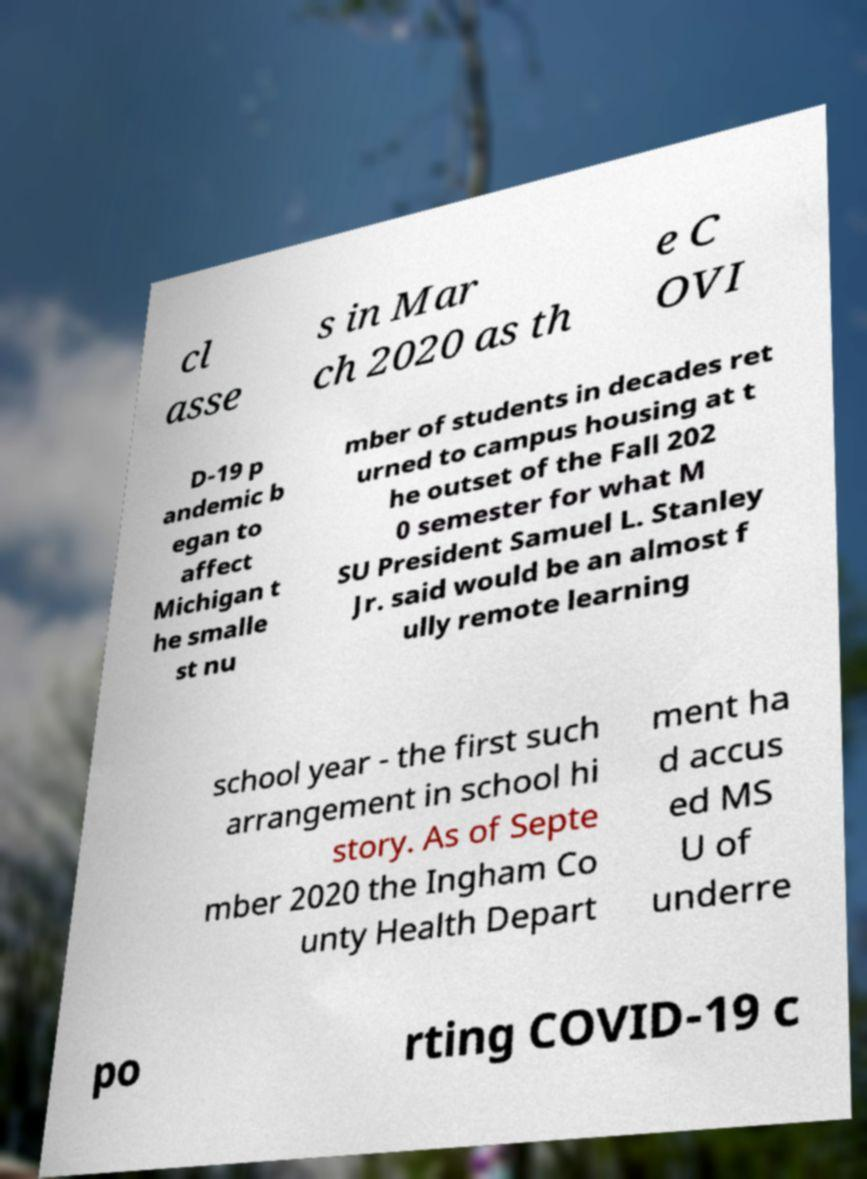Please identify and transcribe the text found in this image. cl asse s in Mar ch 2020 as th e C OVI D-19 p andemic b egan to affect Michigan t he smalle st nu mber of students in decades ret urned to campus housing at t he outset of the Fall 202 0 semester for what M SU President Samuel L. Stanley Jr. said would be an almost f ully remote learning school year - the first such arrangement in school hi story. As of Septe mber 2020 the Ingham Co unty Health Depart ment ha d accus ed MS U of underre po rting COVID-19 c 